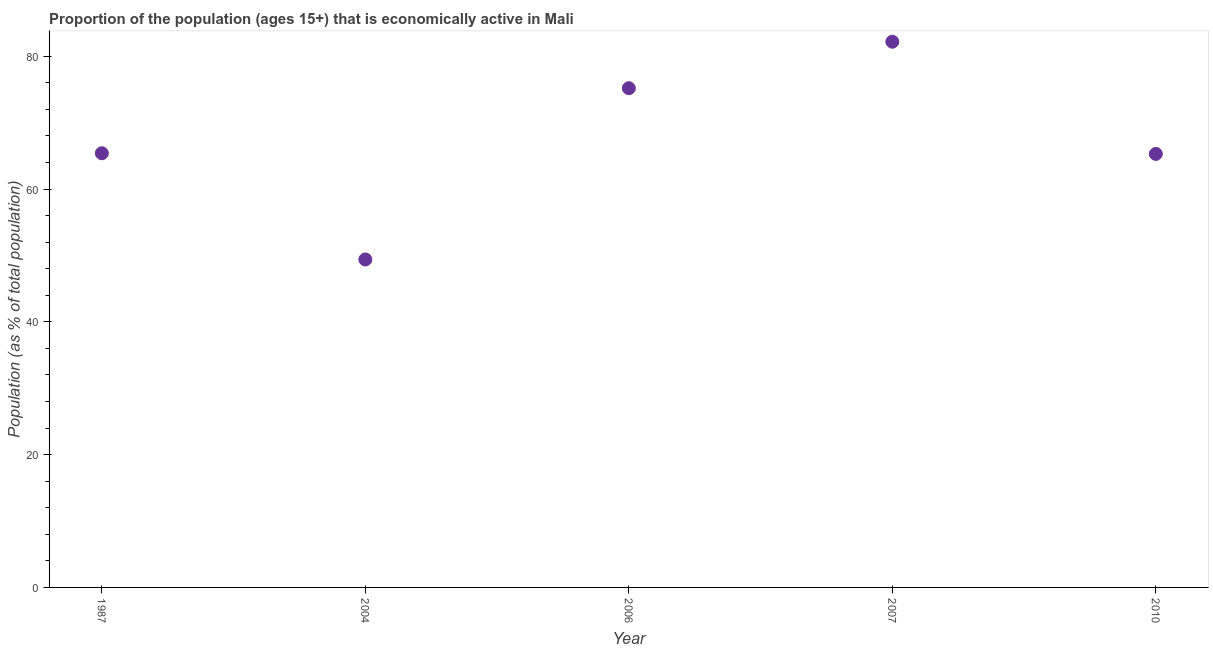What is the percentage of economically active population in 2010?
Make the answer very short. 65.3. Across all years, what is the maximum percentage of economically active population?
Keep it short and to the point. 82.2. Across all years, what is the minimum percentage of economically active population?
Provide a succinct answer. 49.4. In which year was the percentage of economically active population maximum?
Offer a terse response. 2007. What is the sum of the percentage of economically active population?
Your response must be concise. 337.5. What is the difference between the percentage of economically active population in 1987 and 2004?
Offer a very short reply. 16. What is the average percentage of economically active population per year?
Give a very brief answer. 67.5. What is the median percentage of economically active population?
Provide a succinct answer. 65.4. In how many years, is the percentage of economically active population greater than 68 %?
Give a very brief answer. 2. Do a majority of the years between 1987 and 2006 (inclusive) have percentage of economically active population greater than 32 %?
Provide a short and direct response. Yes. What is the ratio of the percentage of economically active population in 1987 to that in 2007?
Offer a very short reply. 0.8. Is the percentage of economically active population in 2006 less than that in 2007?
Give a very brief answer. Yes. Is the difference between the percentage of economically active population in 1987 and 2010 greater than the difference between any two years?
Give a very brief answer. No. What is the difference between the highest and the second highest percentage of economically active population?
Your answer should be compact. 7. What is the difference between the highest and the lowest percentage of economically active population?
Your answer should be very brief. 32.8. Does the percentage of economically active population monotonically increase over the years?
Your response must be concise. No. How many dotlines are there?
Make the answer very short. 1. What is the difference between two consecutive major ticks on the Y-axis?
Keep it short and to the point. 20. What is the title of the graph?
Make the answer very short. Proportion of the population (ages 15+) that is economically active in Mali. What is the label or title of the X-axis?
Offer a terse response. Year. What is the label or title of the Y-axis?
Offer a terse response. Population (as % of total population). What is the Population (as % of total population) in 1987?
Your answer should be very brief. 65.4. What is the Population (as % of total population) in 2004?
Give a very brief answer. 49.4. What is the Population (as % of total population) in 2006?
Make the answer very short. 75.2. What is the Population (as % of total population) in 2007?
Make the answer very short. 82.2. What is the Population (as % of total population) in 2010?
Make the answer very short. 65.3. What is the difference between the Population (as % of total population) in 1987 and 2007?
Give a very brief answer. -16.8. What is the difference between the Population (as % of total population) in 2004 and 2006?
Keep it short and to the point. -25.8. What is the difference between the Population (as % of total population) in 2004 and 2007?
Make the answer very short. -32.8. What is the difference between the Population (as % of total population) in 2004 and 2010?
Make the answer very short. -15.9. What is the difference between the Population (as % of total population) in 2006 and 2010?
Offer a terse response. 9.9. What is the difference between the Population (as % of total population) in 2007 and 2010?
Your answer should be very brief. 16.9. What is the ratio of the Population (as % of total population) in 1987 to that in 2004?
Offer a very short reply. 1.32. What is the ratio of the Population (as % of total population) in 1987 to that in 2006?
Offer a very short reply. 0.87. What is the ratio of the Population (as % of total population) in 1987 to that in 2007?
Your answer should be compact. 0.8. What is the ratio of the Population (as % of total population) in 1987 to that in 2010?
Offer a terse response. 1. What is the ratio of the Population (as % of total population) in 2004 to that in 2006?
Provide a succinct answer. 0.66. What is the ratio of the Population (as % of total population) in 2004 to that in 2007?
Make the answer very short. 0.6. What is the ratio of the Population (as % of total population) in 2004 to that in 2010?
Offer a very short reply. 0.76. What is the ratio of the Population (as % of total population) in 2006 to that in 2007?
Give a very brief answer. 0.92. What is the ratio of the Population (as % of total population) in 2006 to that in 2010?
Ensure brevity in your answer.  1.15. What is the ratio of the Population (as % of total population) in 2007 to that in 2010?
Your answer should be compact. 1.26. 